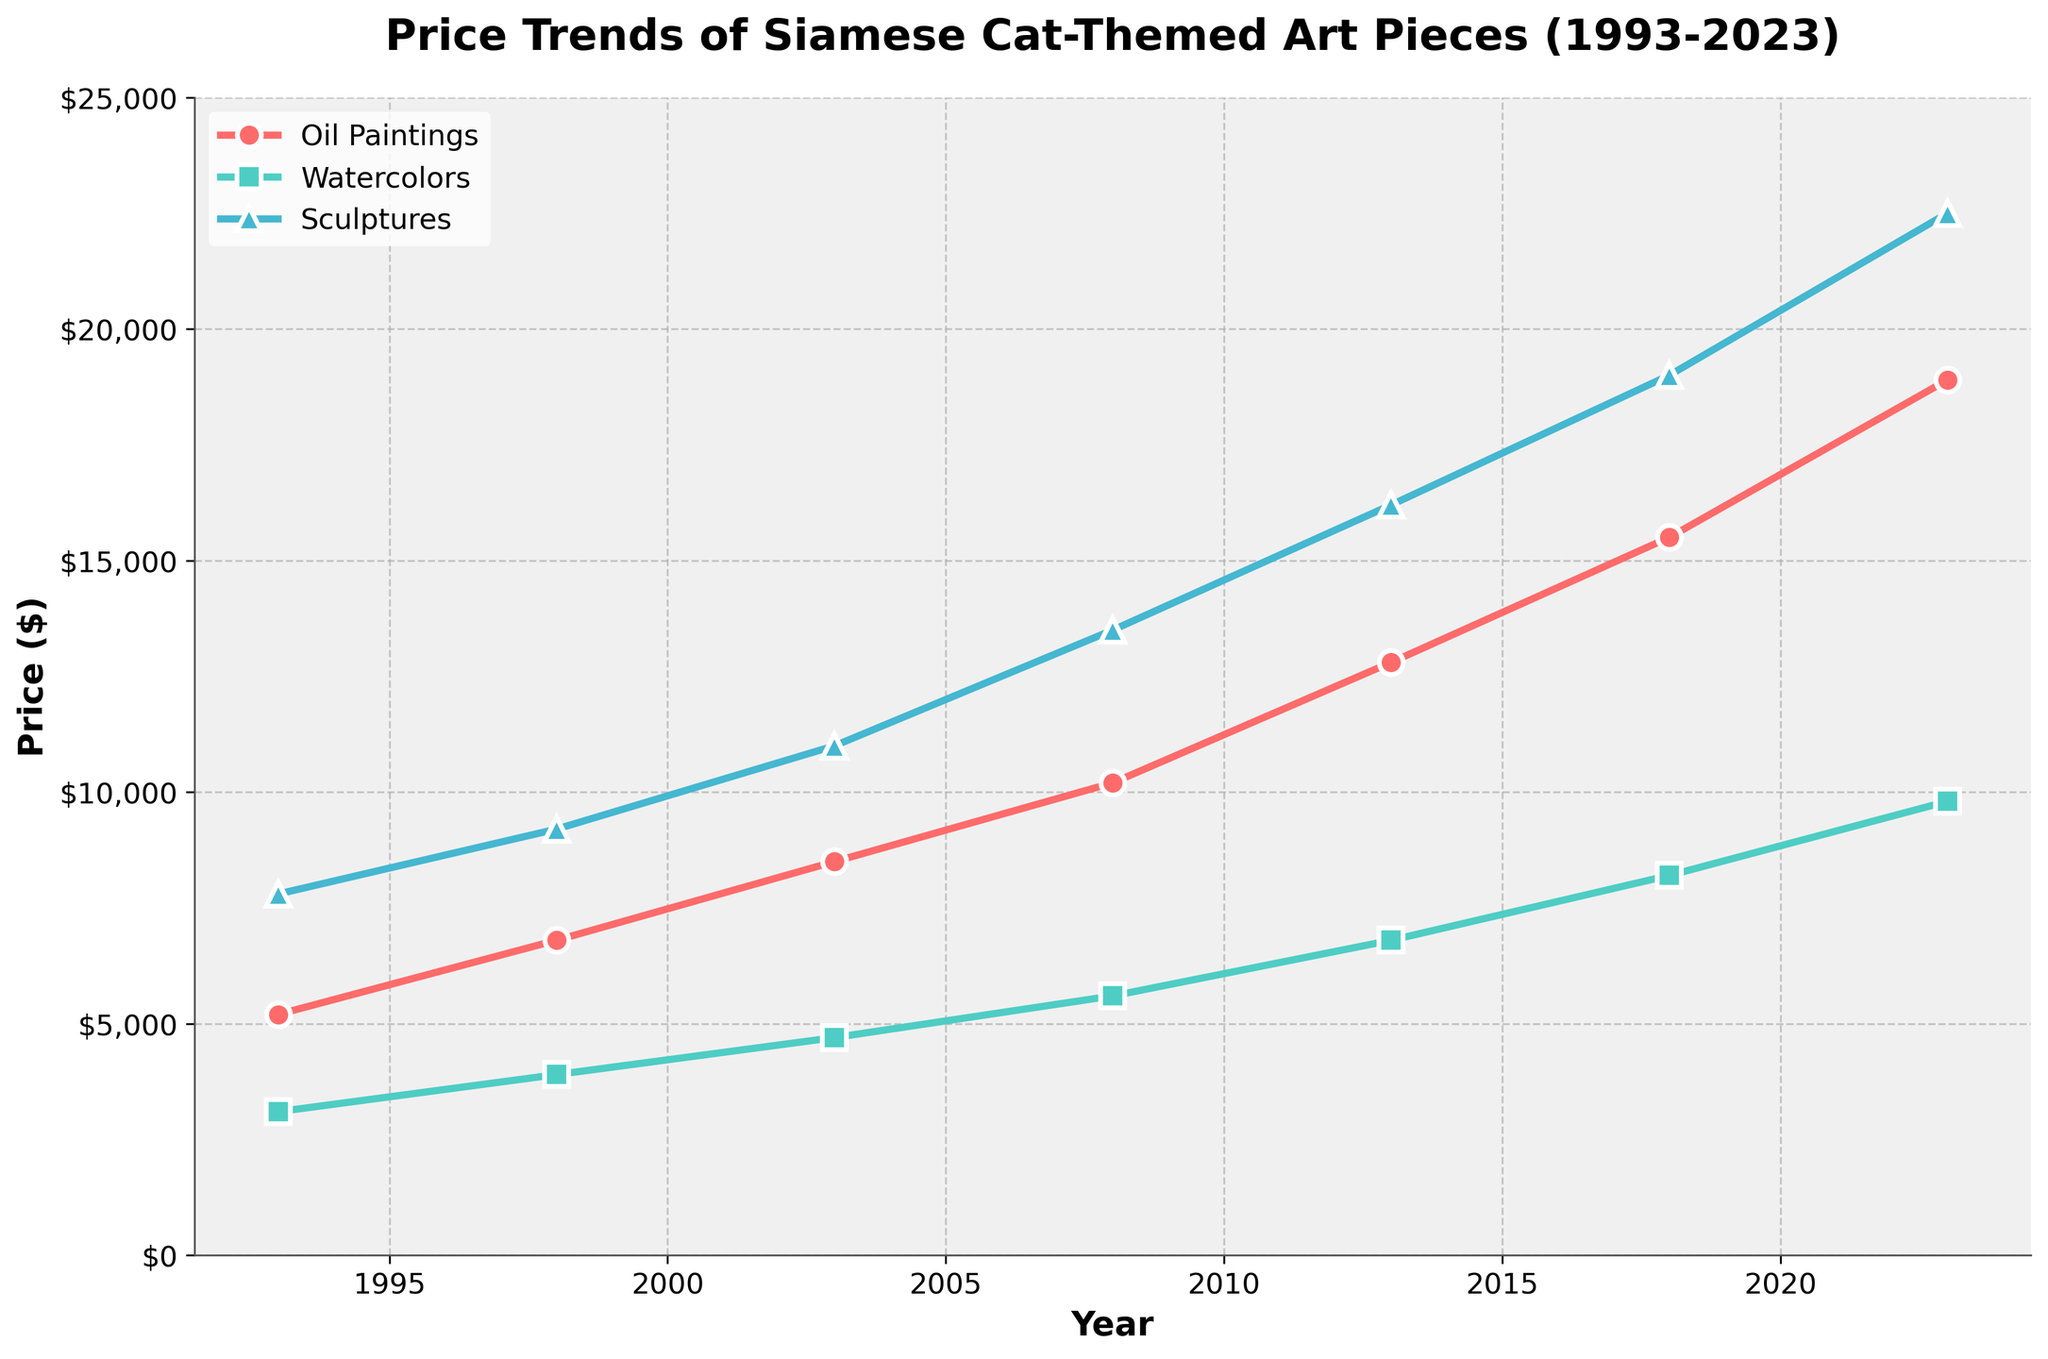How has the average price of Watercolors changed from 1993 to 2023? To find the average price change for Watercolors from 1993 to 2023, we calculate the average for 1993 and 2023 separately then find the difference. For 1993, it's $3100 and for 2023, it's $9800. So, the change in average price is $9800 - $3100 = $6700.
Answer: $6700 Which art medium had the highest price in 2013? By looking at the 2013 data points, we see that Oil Paintings had a price of $12,800, Watercolors had $6,800, and Sculptures had $16,200. The highest price is for Sculptures.
Answer: Sculptures Between which two consecutive time periods did Oil Paintings see the highest increase in price? To figure out the time period with the highest increase, compute the difference between consecutive years for Oil Paintings: 1993-1998: $1600, 1998-2003: $1700, 2003-2008: $1700, 2008-2013: $2600, 2013-2018: $2700, and 2018-2023: $3400. The highest increase is between 2018 and 2023.
Answer: 2018-2023 As of 2023, how much more expensive are Sculptures than Watercolors? For 2023, Sculptures are priced at $22,500 and Watercolors at $9,800. The difference in price is $22,500 - $9,800 = $12,700.
Answer: $12,700 What is the compounded annual growth rate (CAGR) for Oil Paintings from 1993 to 2023? CAGR is calculated as [(Final Value / Initial Value)^(1 / Number of Years)] - 1. For Oil Paintings: Final Value = $18,900, Initial Value = $5,200, Number of Years = 30. CAGR = [(18900 / 5200)^(1 / 30)] - 1 = 0.0601 or 6.01%.
Answer: 6.01% How do the price trends for Sculptures compare to Oil Paintings over the entire period? Analyzing the trend lines from 1993 to 2023, we observe that while the prices for both Sculptures and Oil Paintings increased, the rate for Sculptures ($7,800 to $22,500) seems steeper compared to Oil Paintings ($5,200 to $18,900).
Answer: Steeper increase for Sculptures Did any art medium ever experience a price decrease between any two consecutive periods? Looking at all medium price values for each consecutive period, we observe that none of the art mediums (Oil Paintings, Watercolors, Sculptures) experienced any price decrease; they all show consistent growth.
Answer: No What proportion of the total price in 2023 comes from Watercolors? Calculate the total price in 2023 by summing the prices of all mediums: $18,900 (Oil) + $9,800 (Watercolors) + $22,500 (Sculptures) = $51,200. The proportion for Watercolors: ($9,800 / $51,200) * 100 ≈ 19.14%.
Answer: 19.14% Which category had the lowest average price increase per year from 1993 to 2023? Calculate the average price increase per year for each category. Oil Paintings: ($18,900 - $5,200) / 30 ≈ $458, Watercolors: ($9,800 - $3,100) / 30 ≈ $223, Sculptures: ($22,500 - $7,800) / 30 ≈ $490. Watercolors had the lowest average increase.
Answer: Watercolors In 2008, did Watercolors fall above or below the trend line for Oil Paintings in 2003? From the data, Watercolors in 2008 are priced at $5,600, while Oil Paintings in 2003 are priced at $8,500. $5,600 is below the $8,500 trend line for Oil Paintings.
Answer: Below 